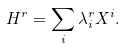Convert formula to latex. <formula><loc_0><loc_0><loc_500><loc_500>H ^ { r } = \sum _ { i } \lambda _ { i } ^ { r } X ^ { i } .</formula> 